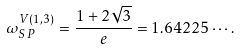<formula> <loc_0><loc_0><loc_500><loc_500>\omega _ { S P } ^ { V ( 1 , 3 ) } = \frac { 1 + 2 \sqrt { 3 } } { e } = 1 . 6 4 2 2 5 \cdots .</formula> 